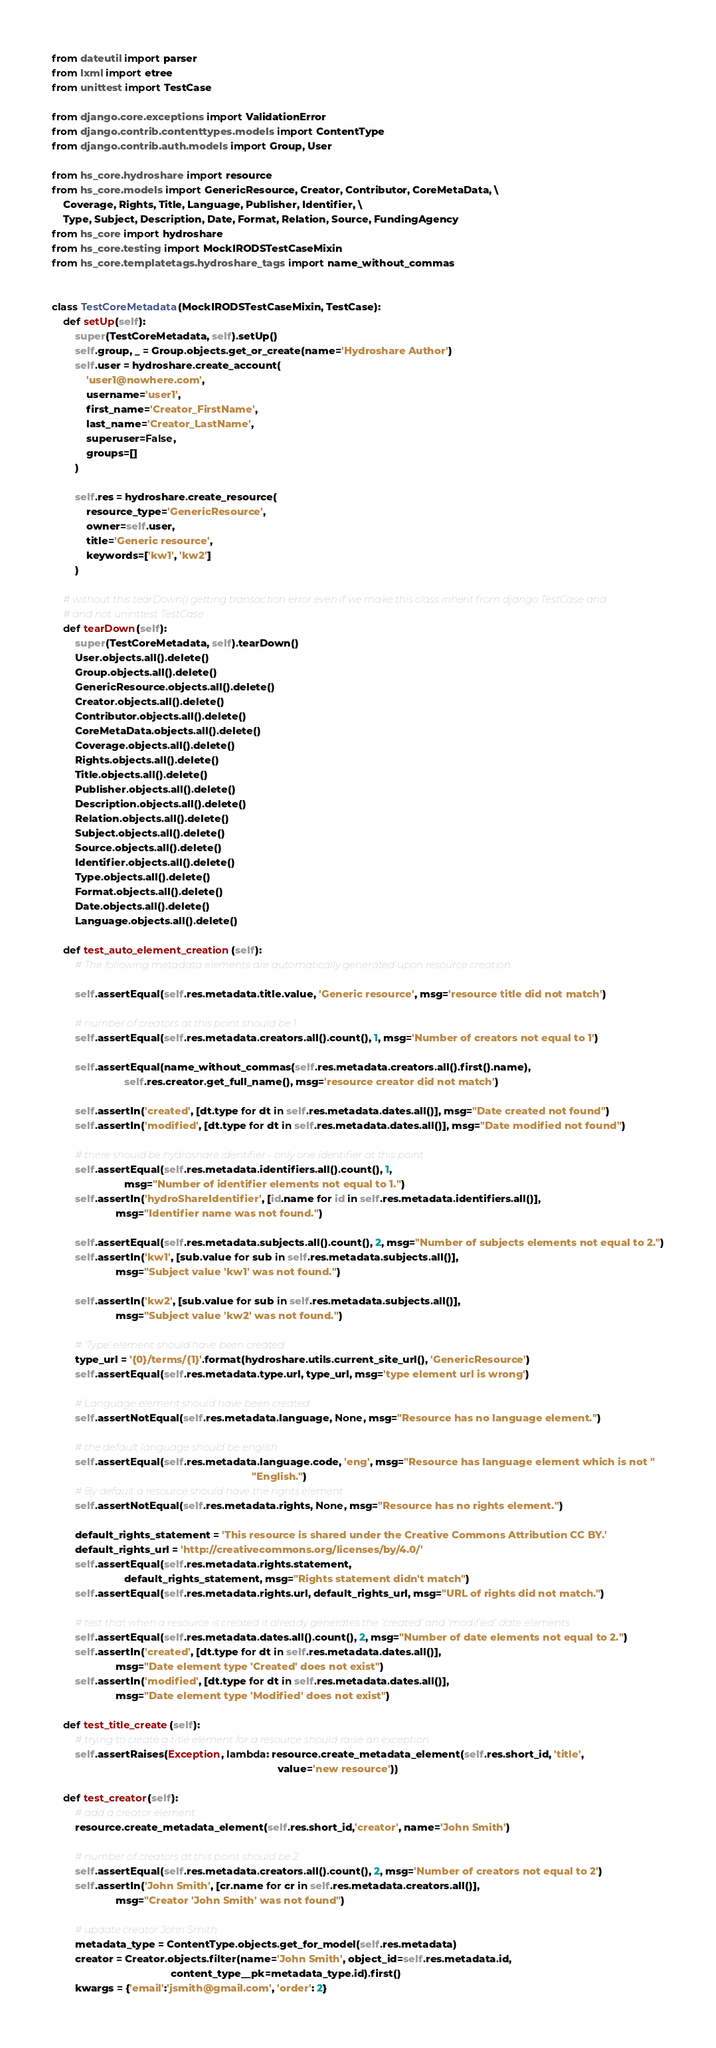Convert code to text. <code><loc_0><loc_0><loc_500><loc_500><_Python_>from dateutil import parser
from lxml import etree
from unittest import TestCase

from django.core.exceptions import ValidationError
from django.contrib.contenttypes.models import ContentType
from django.contrib.auth.models import Group, User

from hs_core.hydroshare import resource
from hs_core.models import GenericResource, Creator, Contributor, CoreMetaData, \
    Coverage, Rights, Title, Language, Publisher, Identifier, \
    Type, Subject, Description, Date, Format, Relation, Source, FundingAgency
from hs_core import hydroshare
from hs_core.testing import MockIRODSTestCaseMixin
from hs_core.templatetags.hydroshare_tags import name_without_commas


class TestCoreMetadata(MockIRODSTestCaseMixin, TestCase):
    def setUp(self):
        super(TestCoreMetadata, self).setUp()
        self.group, _ = Group.objects.get_or_create(name='Hydroshare Author')
        self.user = hydroshare.create_account(
            'user1@nowhere.com',
            username='user1',
            first_name='Creator_FirstName',
            last_name='Creator_LastName',
            superuser=False,
            groups=[]
        )

        self.res = hydroshare.create_resource(
            resource_type='GenericResource',
            owner=self.user,
            title='Generic resource',
            keywords=['kw1', 'kw2']
        )

    # without this tearDown() getting transaction error even if we make this class inherit from django TestCase and
    # and not uninttest TestCase
    def tearDown(self):
        super(TestCoreMetadata, self).tearDown()
        User.objects.all().delete()
        Group.objects.all().delete()
        GenericResource.objects.all().delete()
        Creator.objects.all().delete()
        Contributor.objects.all().delete()
        CoreMetaData.objects.all().delete()
        Coverage.objects.all().delete()
        Rights.objects.all().delete()
        Title.objects.all().delete()
        Publisher.objects.all().delete()
        Description.objects.all().delete()
        Relation.objects.all().delete()
        Subject.objects.all().delete()
        Source.objects.all().delete()
        Identifier.objects.all().delete()
        Type.objects.all().delete()
        Format.objects.all().delete()
        Date.objects.all().delete()
        Language.objects.all().delete()

    def test_auto_element_creation(self):
        # The following metadata elements are automatically generated upon resource creation

        self.assertEqual(self.res.metadata.title.value, 'Generic resource', msg='resource title did not match')

        # number of creators at this point should be 1
        self.assertEqual(self.res.metadata.creators.all().count(), 1, msg='Number of creators not equal to 1')

        self.assertEqual(name_without_commas(self.res.metadata.creators.all().first().name),
                         self.res.creator.get_full_name(), msg='resource creator did not match')

        self.assertIn('created', [dt.type for dt in self.res.metadata.dates.all()], msg="Date created not found")
        self.assertIn('modified', [dt.type for dt in self.res.metadata.dates.all()], msg="Date modified not found")

        # there should be hydroshare identifier - only one identifier at this point
        self.assertEqual(self.res.metadata.identifiers.all().count(), 1,
                         msg="Number of identifier elements not equal to 1.")
        self.assertIn('hydroShareIdentifier', [id.name for id in self.res.metadata.identifiers.all()],
                      msg="Identifier name was not found.")

        self.assertEqual(self.res.metadata.subjects.all().count(), 2, msg="Number of subjects elements not equal to 2.")
        self.assertIn('kw1', [sub.value for sub in self.res.metadata.subjects.all()],
                      msg="Subject value 'kw1' was not found.")

        self.assertIn('kw2', [sub.value for sub in self.res.metadata.subjects.all()],
                      msg="Subject value 'kw2' was not found.")

        # 'Type' element should have been created
        type_url = '{0}/terms/{1}'.format(hydroshare.utils.current_site_url(), 'GenericResource')
        self.assertEqual(self.res.metadata.type.url, type_url, msg='type element url is wrong')

        # Language element should have been created
        self.assertNotEqual(self.res.metadata.language, None, msg="Resource has no language element.")

        # the default language should be english
        self.assertEqual(self.res.metadata.language.code, 'eng', msg="Resource has language element which is not "
                                                                     "English.")
        # By default a resource should have the rights element
        self.assertNotEqual(self.res.metadata.rights, None, msg="Resource has no rights element.")

        default_rights_statement = 'This resource is shared under the Creative Commons Attribution CC BY.'
        default_rights_url = 'http://creativecommons.org/licenses/by/4.0/'
        self.assertEqual(self.res.metadata.rights.statement,
                         default_rights_statement, msg="Rights statement didn't match")
        self.assertEqual(self.res.metadata.rights.url, default_rights_url, msg="URL of rights did not match.")

        # test that when a resource is created it already generates the 'created' and 'modified' date elements
        self.assertEqual(self.res.metadata.dates.all().count(), 2, msg="Number of date elements not equal to 2.")
        self.assertIn('created', [dt.type for dt in self.res.metadata.dates.all()],
                      msg="Date element type 'Created' does not exist")
        self.assertIn('modified', [dt.type for dt in self.res.metadata.dates.all()],
                      msg="Date element type 'Modified' does not exist")

    def test_title_create(self):
        # trying to create a title element for a resource should raise an exception
        self.assertRaises(Exception, lambda: resource.create_metadata_element(self.res.short_id, 'title',
                                                                              value='new resource'))

    def test_creator(self):
        # add a creator element
        resource.create_metadata_element(self.res.short_id,'creator', name='John Smith')

        # number of creators at this point should be 2
        self.assertEqual(self.res.metadata.creators.all().count(), 2, msg='Number of creators not equal to 2')
        self.assertIn('John Smith', [cr.name for cr in self.res.metadata.creators.all()],
                      msg="Creator 'John Smith' was not found")

        # update creator John Smith
        metadata_type = ContentType.objects.get_for_model(self.res.metadata)
        creator = Creator.objects.filter(name='John Smith', object_id=self.res.metadata.id,
                                         content_type__pk=metadata_type.id).first()
        kwargs = {'email':'jsmith@gmail.com', 'order': 2}</code> 